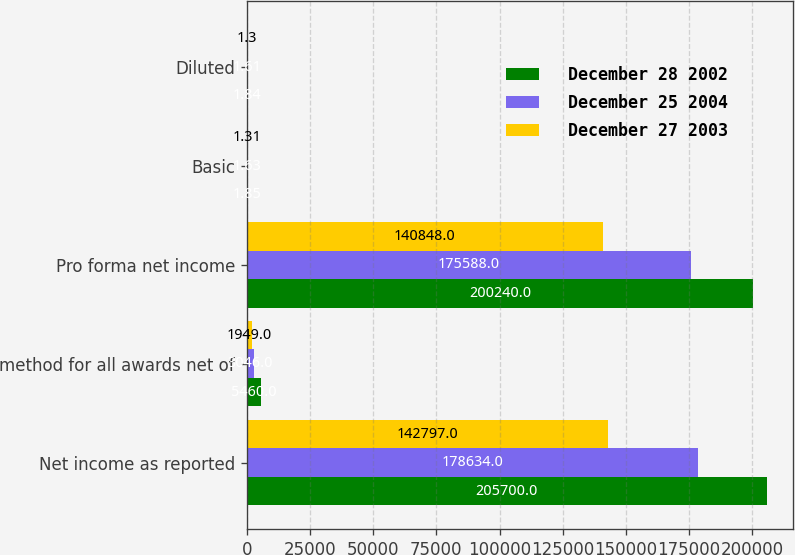Convert chart. <chart><loc_0><loc_0><loc_500><loc_500><stacked_bar_chart><ecel><fcel>Net income as reported<fcel>method for all awards net of<fcel>Pro forma net income<fcel>Basic<fcel>Diluted<nl><fcel>December 28 2002<fcel>205700<fcel>5460<fcel>200240<fcel>1.85<fcel>1.84<nl><fcel>December 25 2004<fcel>178634<fcel>3046<fcel>175588<fcel>1.63<fcel>1.61<nl><fcel>December 27 2003<fcel>142797<fcel>1949<fcel>140848<fcel>1.31<fcel>1.3<nl></chart> 